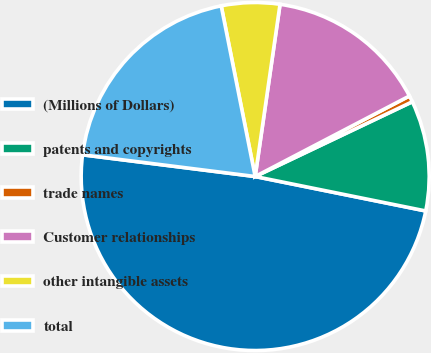Convert chart. <chart><loc_0><loc_0><loc_500><loc_500><pie_chart><fcel>(Millions of Dollars)<fcel>patents and copyrights<fcel>trade names<fcel>Customer relationships<fcel>other intangible assets<fcel>total<nl><fcel>48.82%<fcel>10.24%<fcel>0.59%<fcel>15.06%<fcel>5.41%<fcel>19.88%<nl></chart> 